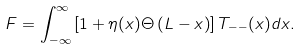Convert formula to latex. <formula><loc_0><loc_0><loc_500><loc_500>F = \int _ { - \infty } ^ { \infty } \left [ 1 + \eta ( x ) \Theta \left ( L - x \right ) \right ] T _ { - - } ( x ) d x .</formula> 